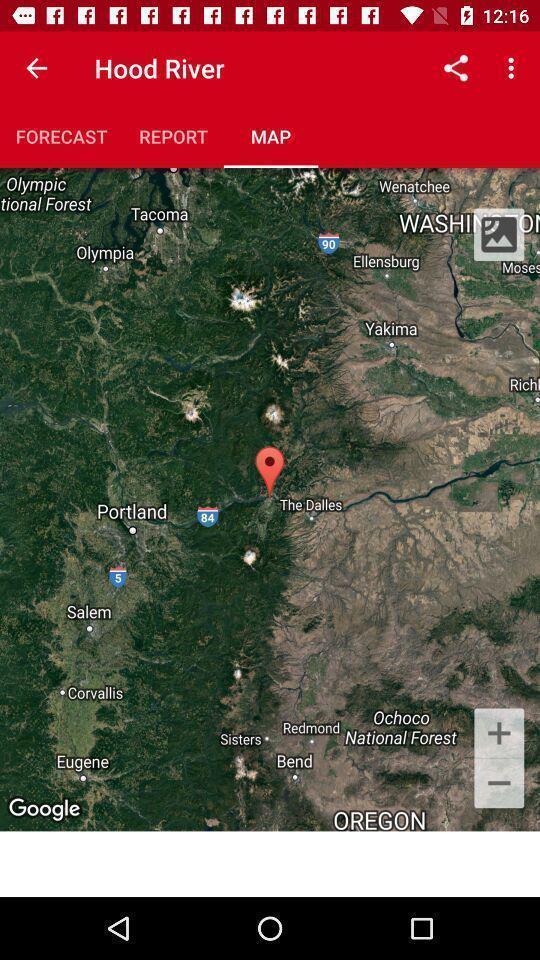What can you discern from this picture? Showing location the map app. 